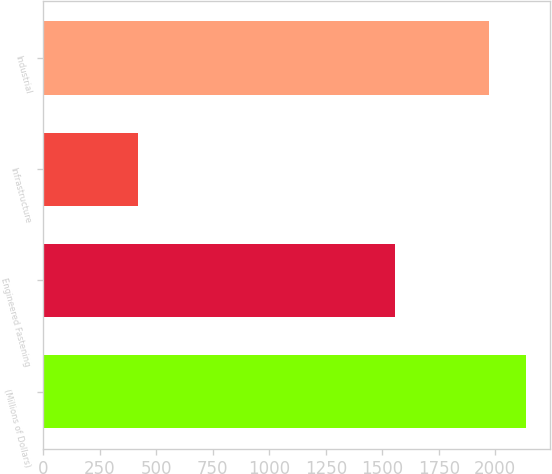Convert chart. <chart><loc_0><loc_0><loc_500><loc_500><bar_chart><fcel>(Millions of Dollars)<fcel>Engineered Fastening<fcel>Infrastructure<fcel>Industrial<nl><fcel>2134<fcel>1554.3<fcel>420<fcel>1974.3<nl></chart> 